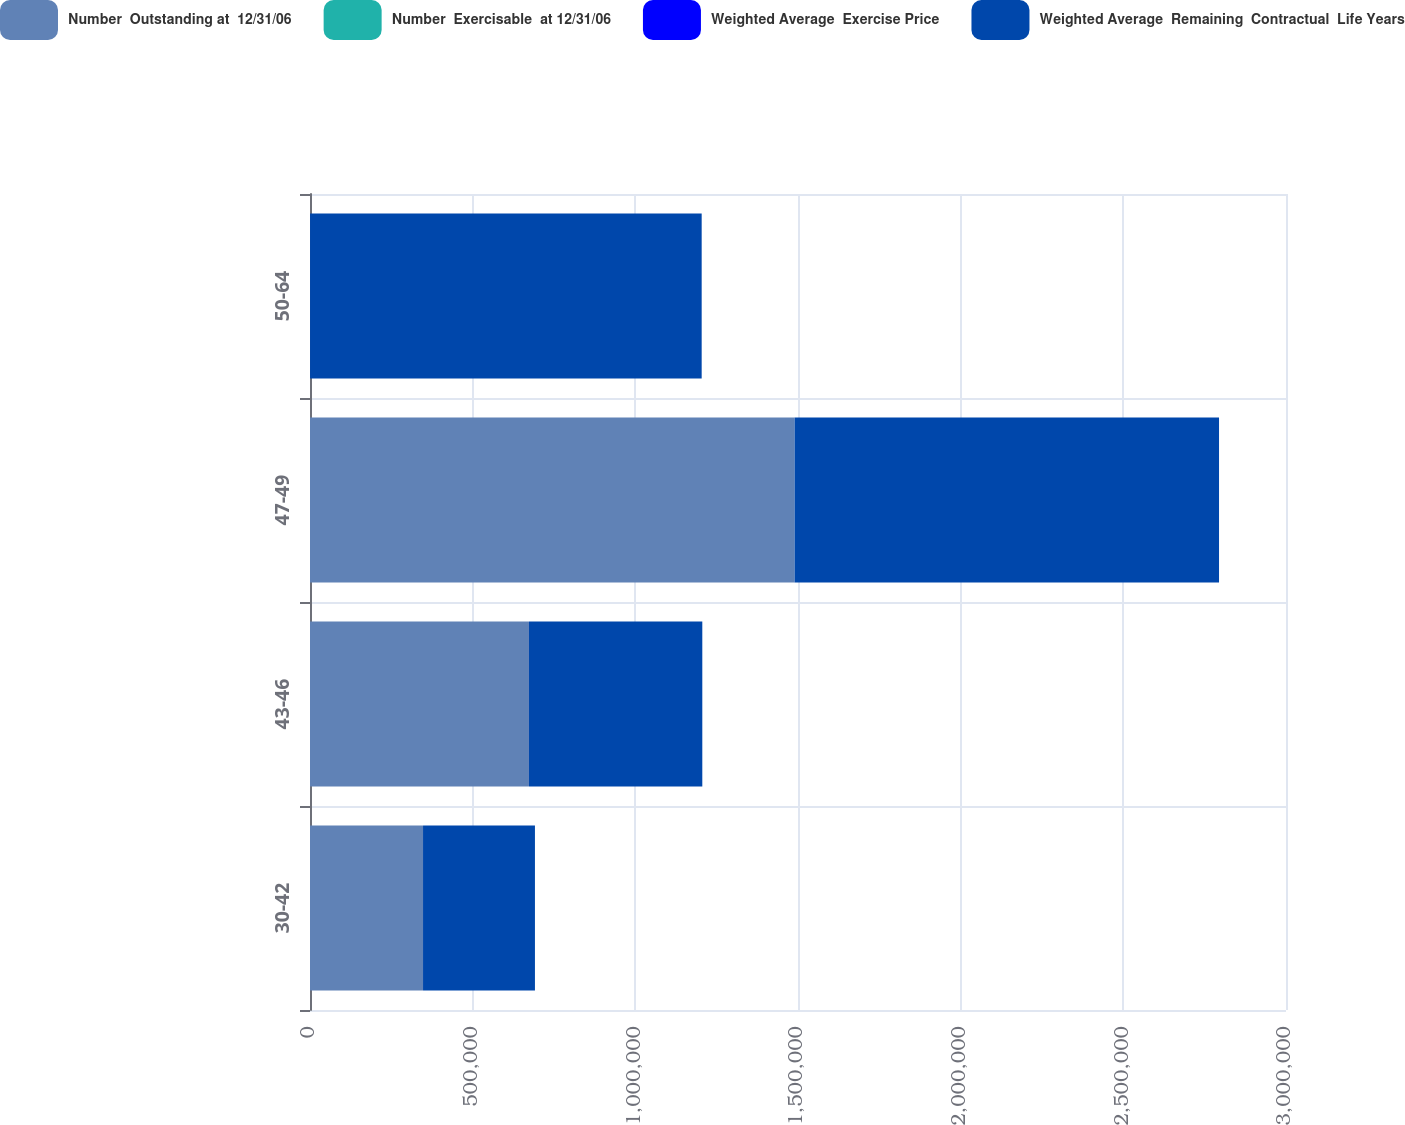Convert chart to OTSL. <chart><loc_0><loc_0><loc_500><loc_500><stacked_bar_chart><ecel><fcel>30-42<fcel>43-46<fcel>47-49<fcel>50-64<nl><fcel>Number  Outstanding at  12/31/06<fcel>347400<fcel>673000<fcel>1.4896e+06<fcel>58<nl><fcel>Number  Exercisable  at 12/31/06<fcel>5.7<fcel>4.9<fcel>5.6<fcel>7.5<nl><fcel>Weighted Average  Exercise Price<fcel>31<fcel>45<fcel>48<fcel>58<nl><fcel>Weighted Average  Remaining  Contractual  Life Years<fcel>344000<fcel>532800<fcel>1.3045e+06<fcel>1.2038e+06<nl></chart> 